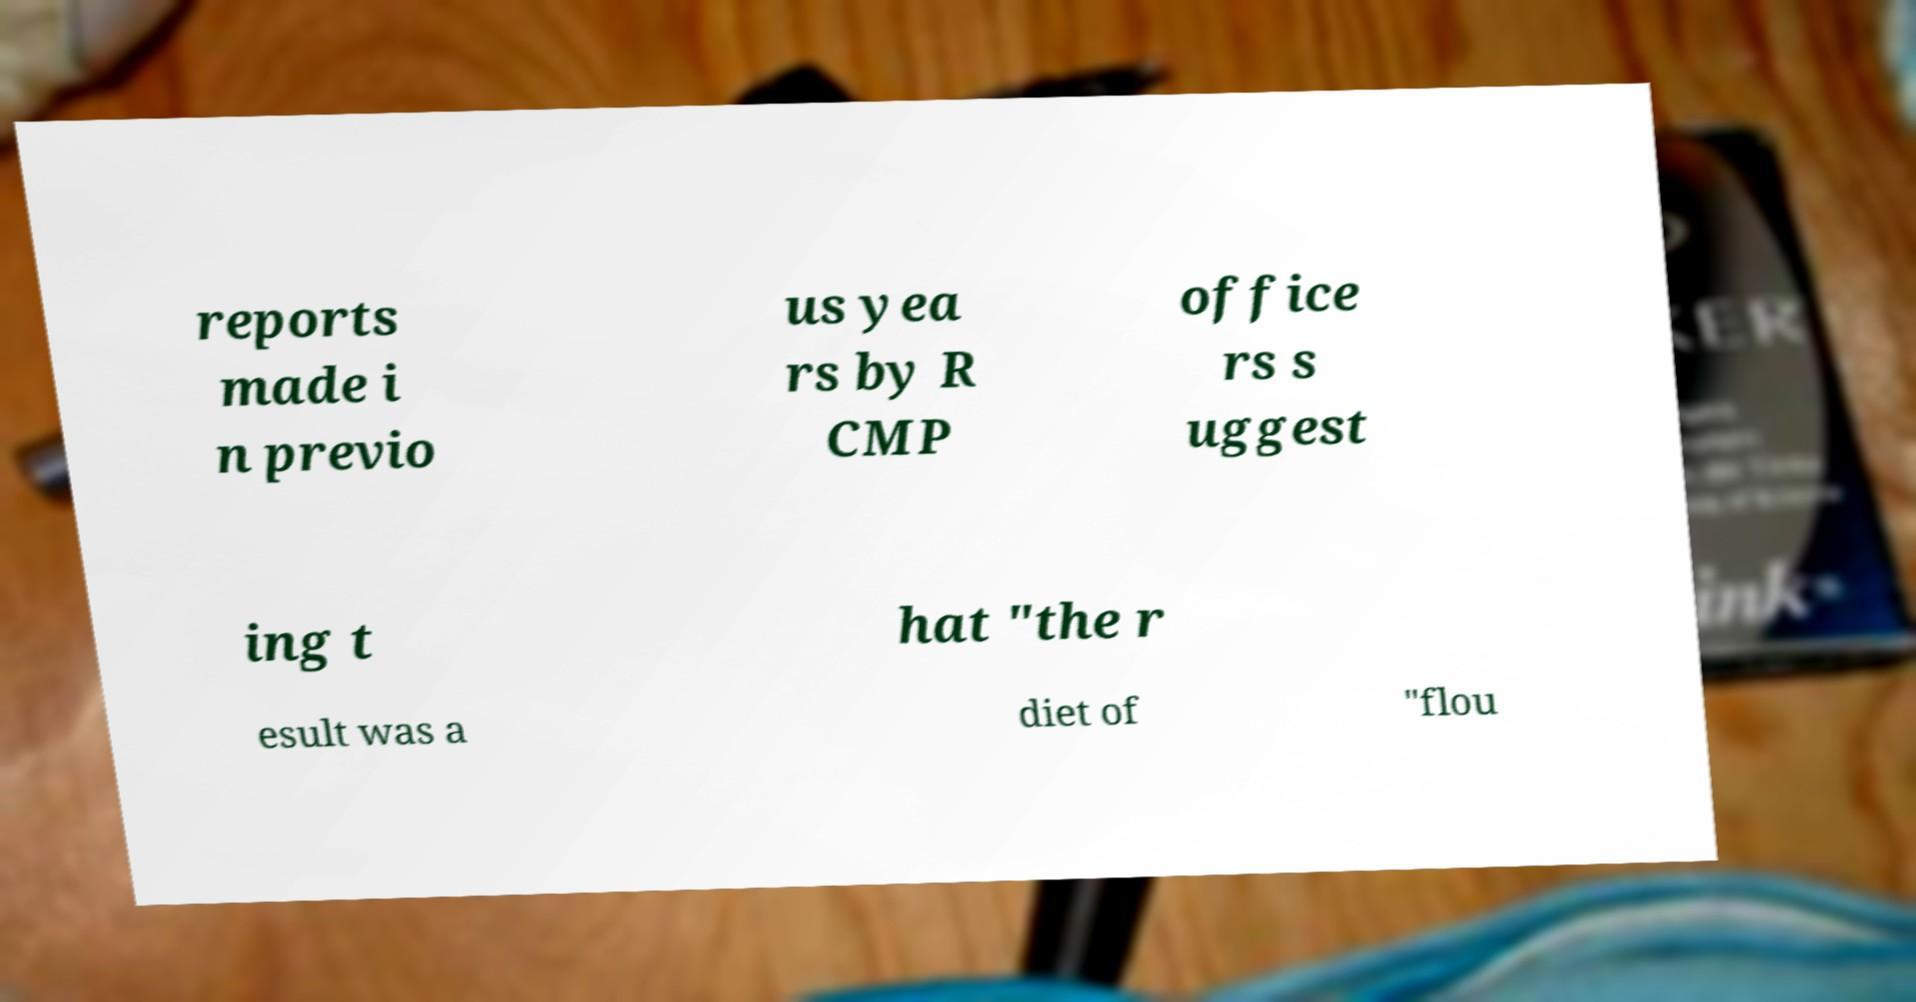Can you accurately transcribe the text from the provided image for me? reports made i n previo us yea rs by R CMP office rs s uggest ing t hat "the r esult was a diet of "flou 